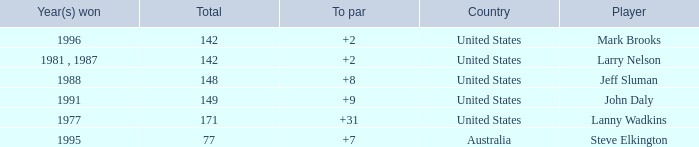Help me parse the entirety of this table. {'header': ['Year(s) won', 'Total', 'To par', 'Country', 'Player'], 'rows': [['1996', '142', '+2', 'United States', 'Mark Brooks'], ['1981 , 1987', '142', '+2', 'United States', 'Larry Nelson'], ['1988', '148', '+8', 'United States', 'Jeff Sluman'], ['1991', '149', '+9', 'United States', 'John Daly'], ['1977', '171', '+31', 'United States', 'Lanny Wadkins'], ['1995', '77', '+7', 'Australia', 'Steve Elkington']]} Name the Total of australia and a To par smaller than 7? None. 